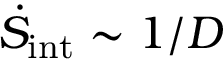<formula> <loc_0><loc_0><loc_500><loc_500>\dot { S } _ { i n t } \sim 1 / D</formula> 